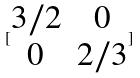<formula> <loc_0><loc_0><loc_500><loc_500>[ \begin{matrix} 3 / 2 & 0 \\ 0 & 2 / 3 \end{matrix} ]</formula> 